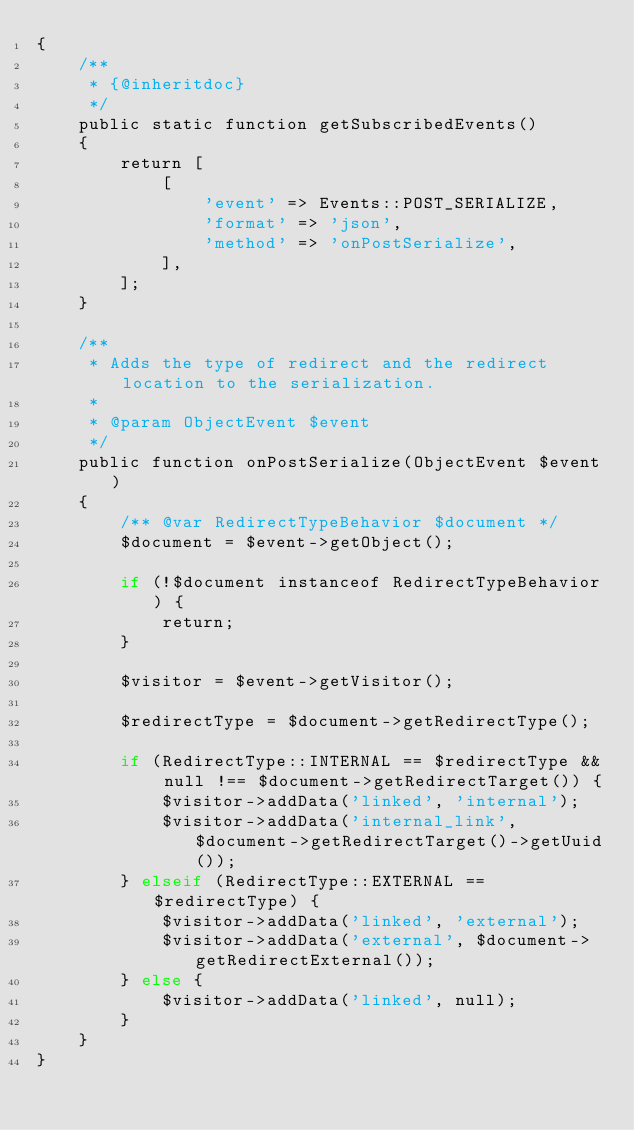<code> <loc_0><loc_0><loc_500><loc_500><_PHP_>{
    /**
     * {@inheritdoc}
     */
    public static function getSubscribedEvents()
    {
        return [
            [
                'event' => Events::POST_SERIALIZE,
                'format' => 'json',
                'method' => 'onPostSerialize',
            ],
        ];
    }

    /**
     * Adds the type of redirect and the redirect location to the serialization.
     *
     * @param ObjectEvent $event
     */
    public function onPostSerialize(ObjectEvent $event)
    {
        /** @var RedirectTypeBehavior $document */
        $document = $event->getObject();

        if (!$document instanceof RedirectTypeBehavior) {
            return;
        }

        $visitor = $event->getVisitor();

        $redirectType = $document->getRedirectType();

        if (RedirectType::INTERNAL == $redirectType && null !== $document->getRedirectTarget()) {
            $visitor->addData('linked', 'internal');
            $visitor->addData('internal_link', $document->getRedirectTarget()->getUuid());
        } elseif (RedirectType::EXTERNAL == $redirectType) {
            $visitor->addData('linked', 'external');
            $visitor->addData('external', $document->getRedirectExternal());
        } else {
            $visitor->addData('linked', null);
        }
    }
}
</code> 